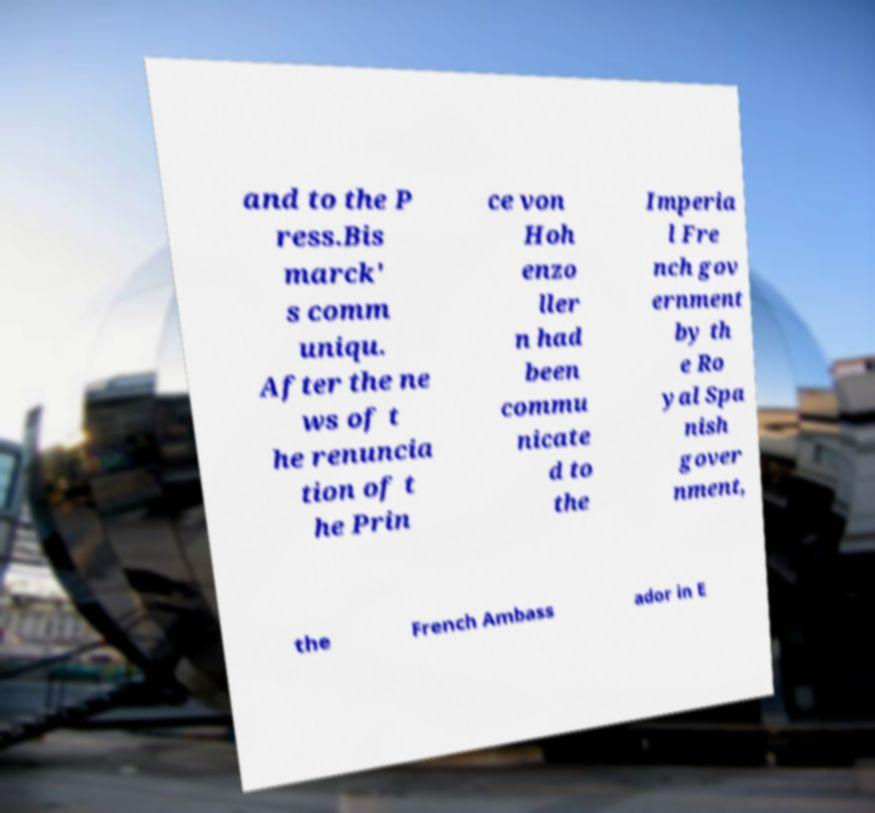What messages or text are displayed in this image? I need them in a readable, typed format. and to the P ress.Bis marck' s comm uniqu. After the ne ws of t he renuncia tion of t he Prin ce von Hoh enzo ller n had been commu nicate d to the Imperia l Fre nch gov ernment by th e Ro yal Spa nish gover nment, the French Ambass ador in E 